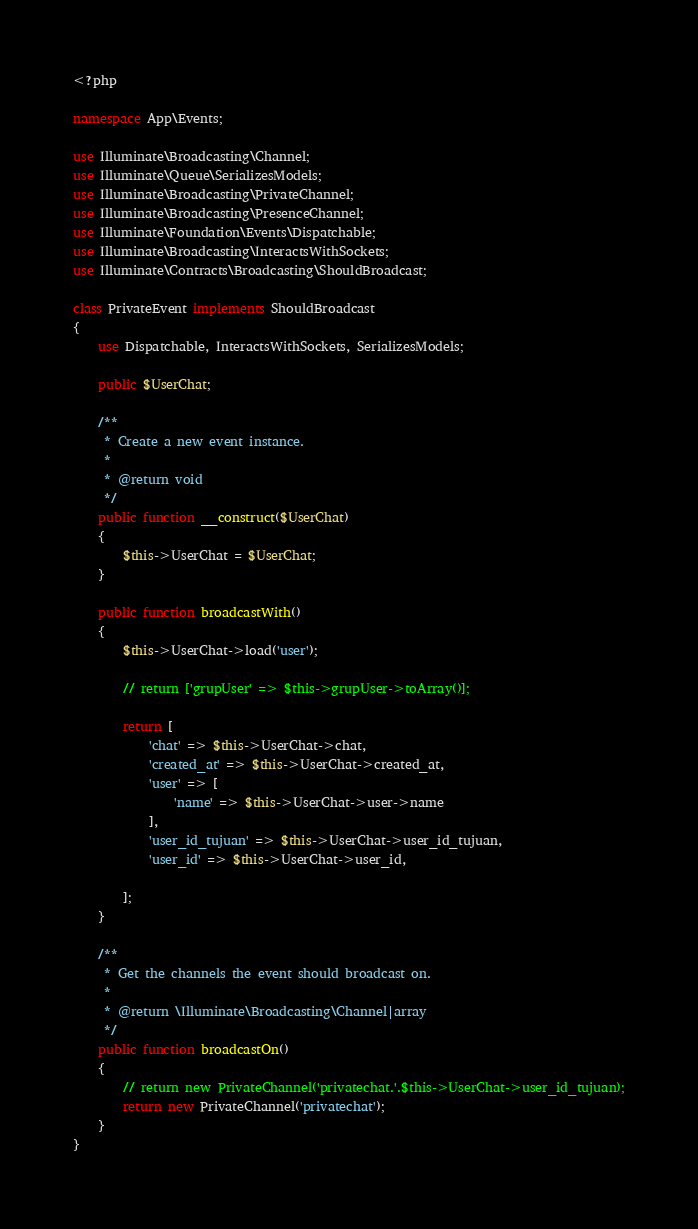Convert code to text. <code><loc_0><loc_0><loc_500><loc_500><_PHP_><?php

namespace App\Events;

use Illuminate\Broadcasting\Channel;
use Illuminate\Queue\SerializesModels;
use Illuminate\Broadcasting\PrivateChannel;
use Illuminate\Broadcasting\PresenceChannel;
use Illuminate\Foundation\Events\Dispatchable;
use Illuminate\Broadcasting\InteractsWithSockets;
use Illuminate\Contracts\Broadcasting\ShouldBroadcast;

class PrivateEvent implements ShouldBroadcast
{
    use Dispatchable, InteractsWithSockets, SerializesModels;

    public $UserChat;

    /**
     * Create a new event instance.
     *
     * @return void
     */
    public function __construct($UserChat)
    {
        $this->UserChat = $UserChat;
    }

    public function broadcastWith()
    {
        $this->UserChat->load('user');

        // return ['grupUser' => $this->grupUser->toArray()];

        return [
            'chat' => $this->UserChat->chat,
            'created_at' => $this->UserChat->created_at,
            'user' => [
                'name' => $this->UserChat->user->name
            ], 
            'user_id_tujuan' => $this->UserChat->user_id_tujuan,
            'user_id' => $this->UserChat->user_id,
            
        ];
    }

    /**
     * Get the channels the event should broadcast on.
     *
     * @return \Illuminate\Broadcasting\Channel|array
     */
    public function broadcastOn()
    {
        // return new PrivateChannel('privatechat.'.$this->UserChat->user_id_tujuan);
        return new PrivateChannel('privatechat');
    }
}
</code> 